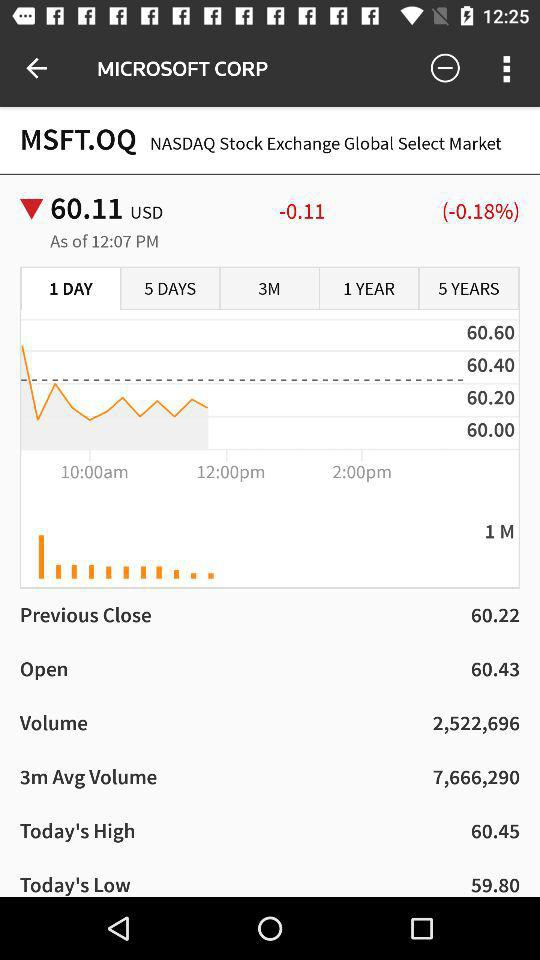What is the percentage change between the current price and the previous close?
Answer the question using a single word or phrase. -0.18% 